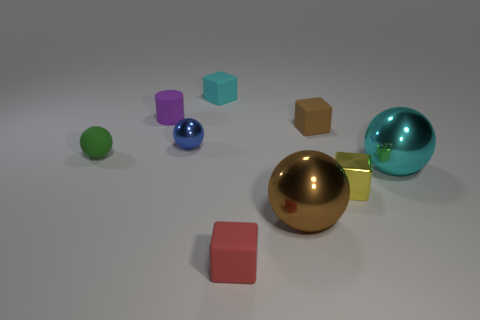Add 1 green rubber things. How many objects exist? 10 Subtract all green cubes. Subtract all brown spheres. How many cubes are left? 4 Subtract all spheres. How many objects are left? 5 Add 2 blue things. How many blue things are left? 3 Add 9 big blue metal objects. How many big blue metal objects exist? 9 Subtract 1 yellow blocks. How many objects are left? 8 Subtract all tiny cyan cylinders. Subtract all small purple matte cylinders. How many objects are left? 8 